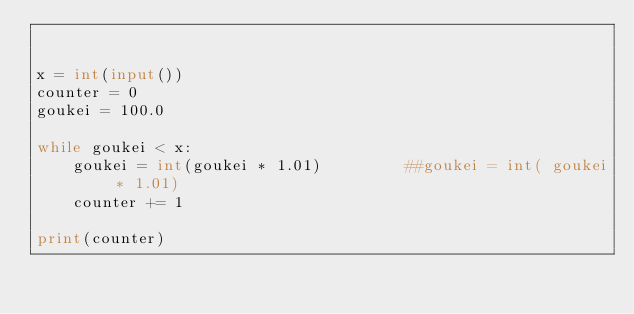Convert code to text. <code><loc_0><loc_0><loc_500><loc_500><_Python_>

x = int(input())
counter = 0
goukei = 100.0

while goukei < x:
    goukei = int(goukei * 1.01)         ##goukei = int( goukei * 1.01)
    counter += 1
    
print(counter)



</code> 